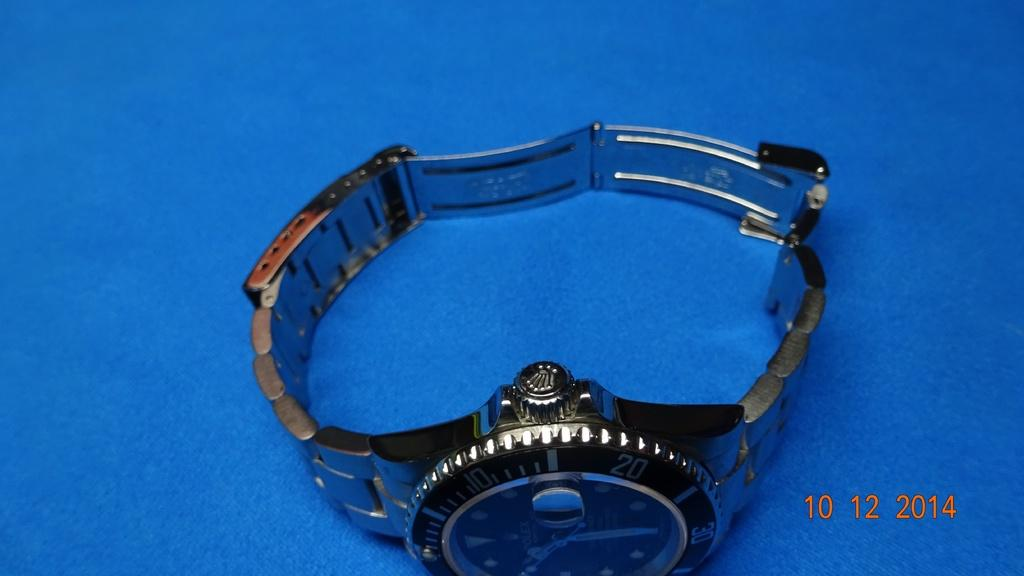Provide a one-sentence caption for the provided image. A photo of a wristwatch with a metal band, bears the time stamp 10 12 2014. 